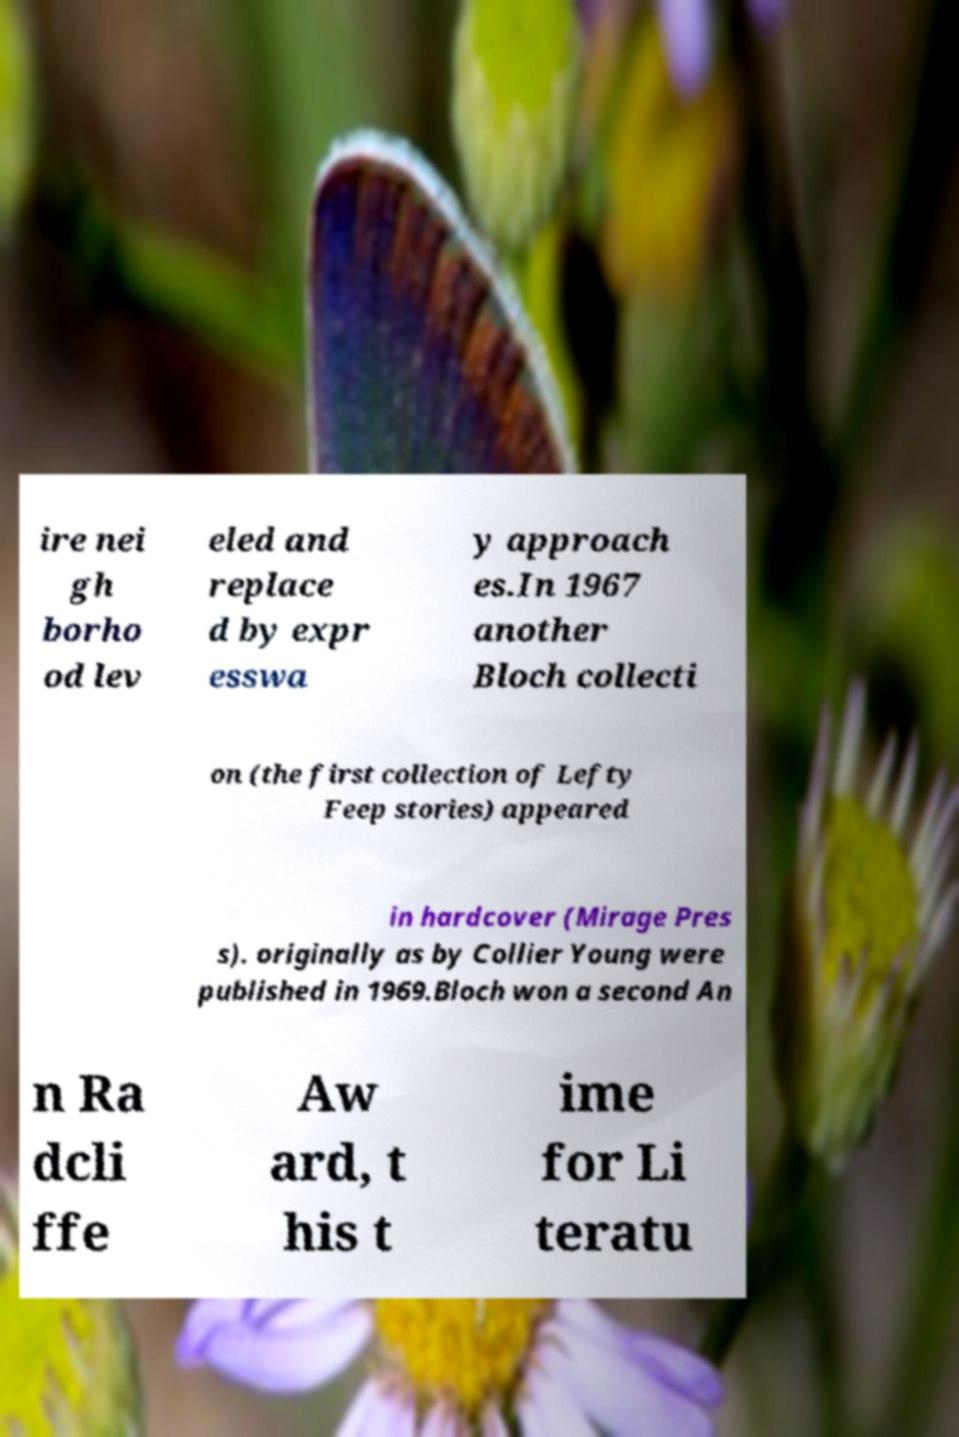What messages or text are displayed in this image? I need them in a readable, typed format. ire nei gh borho od lev eled and replace d by expr esswa y approach es.In 1967 another Bloch collecti on (the first collection of Lefty Feep stories) appeared in hardcover (Mirage Pres s). originally as by Collier Young were published in 1969.Bloch won a second An n Ra dcli ffe Aw ard, t his t ime for Li teratu 